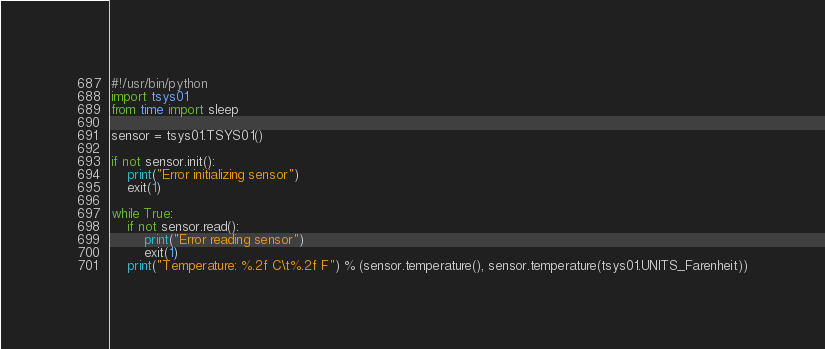<code> <loc_0><loc_0><loc_500><loc_500><_Python_>#!/usr/bin/python
import tsys01
from time import sleep

sensor = tsys01.TSYS01()

if not sensor.init():
    print("Error initializing sensor")
    exit(1)

while True:
    if not sensor.read():
        print("Error reading sensor")
        exit(1)
    print("Temperature: %.2f C\t%.2f F") % (sensor.temperature(), sensor.temperature(tsys01.UNITS_Farenheit))</code> 